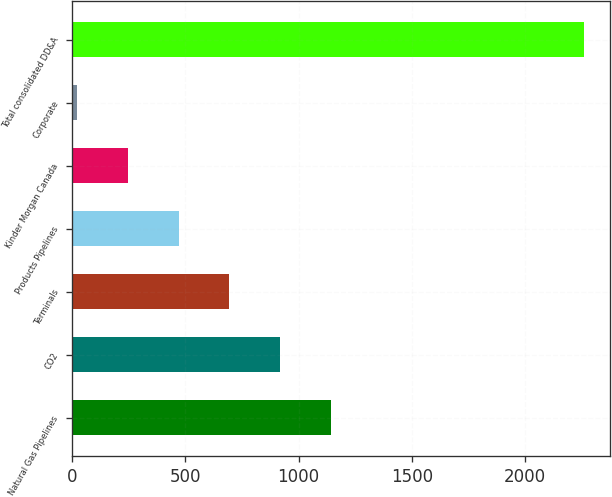Convert chart to OTSL. <chart><loc_0><loc_0><loc_500><loc_500><bar_chart><fcel>Natural Gas Pipelines<fcel>CO2<fcel>Terminals<fcel>Products Pipelines<fcel>Kinder Morgan Canada<fcel>Corporate<fcel>Total consolidated DD&A<nl><fcel>1142<fcel>918.2<fcel>694.4<fcel>470.6<fcel>246.8<fcel>23<fcel>2261<nl></chart> 